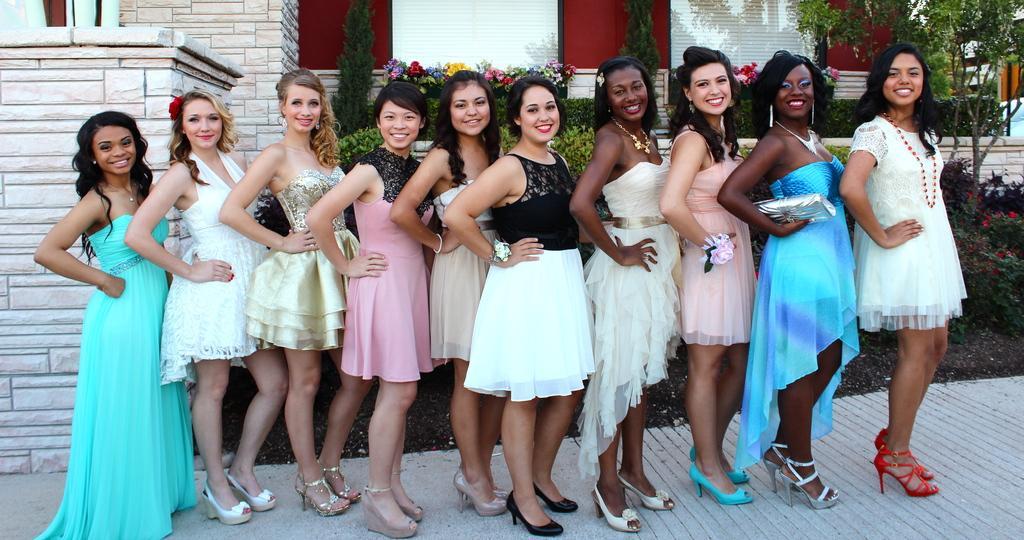Can you describe this image briefly? In this image I can see the group of people are standing and wearing different color dresses. I can see the building, flowers and few plants. 